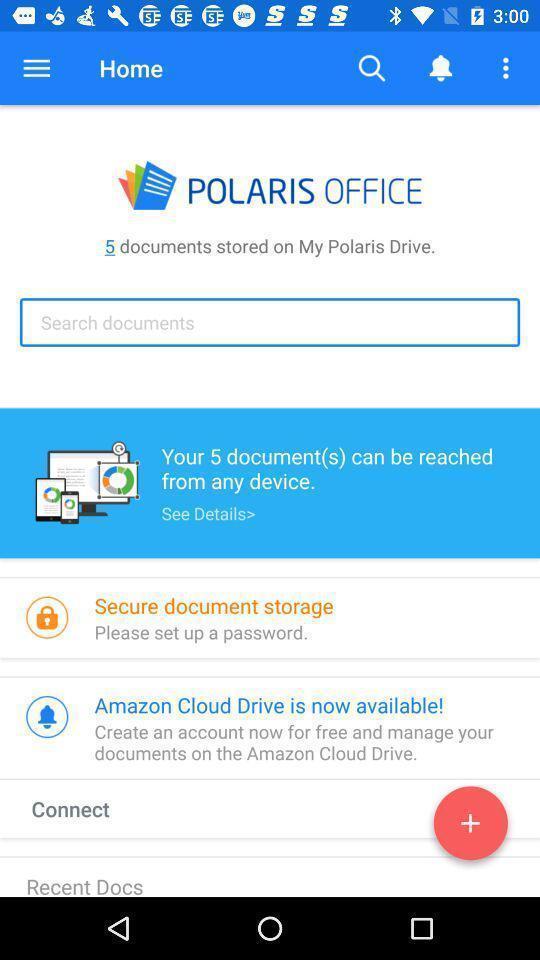What details can you identify in this image? Screen page displaying various details of storage app. 